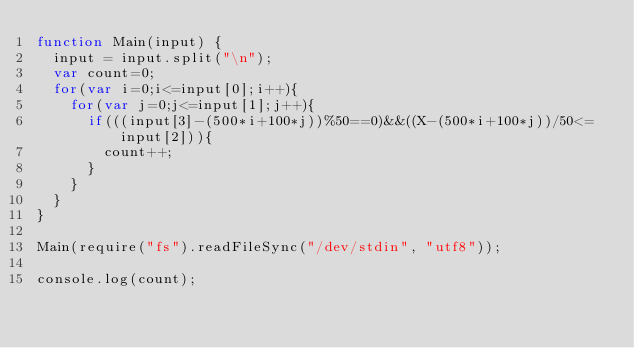<code> <loc_0><loc_0><loc_500><loc_500><_JavaScript_>function Main(input) {
  input = input.split("\n");
  var count=0;
  for(var i=0;i<=input[0];i++){
    for(var j=0;j<=input[1];j++){
      if(((input[3]-(500*i+100*j))%50==0)&&((X-(500*i+100*j))/50<=input[2])){
        count++;
      }
    }
  }
}

Main(require("fs").readFileSync("/dev/stdin", "utf8"));

console.log(count);</code> 